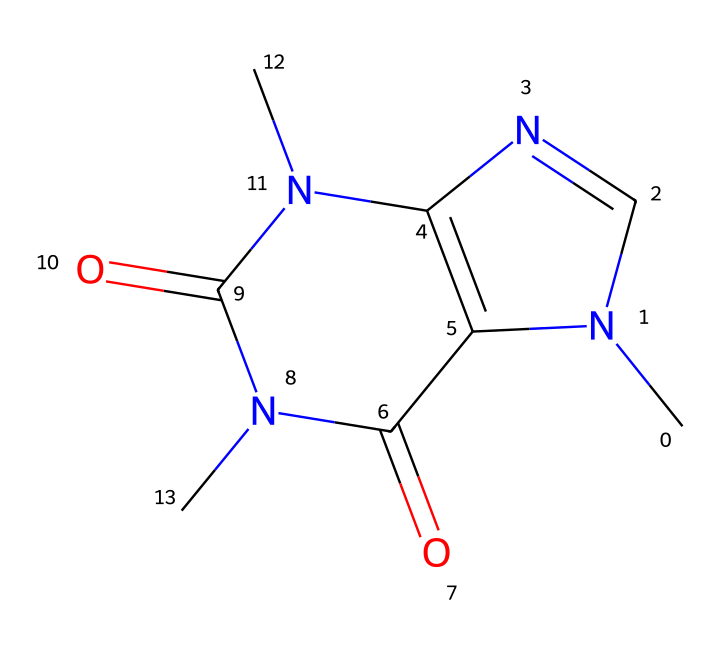What is the molecular formula of this compound? To derive the molecular formula, we identify the individual atoms in the compound using the SMILES notation. The structure reveals the presence of 8 carbon atoms (C), 10 hydrogen atoms (H), 4 nitrogen atoms (N), and 2 oxygen atoms (O). Therefore, the complete molecular formula is C8H10N4O2.
Answer: C8H10N4O2 How many rings are present in the structure? By analyzing the SMILES representation, we can identify the ring closures indicated by the numbers. The structure has two numbered sections, indicating that there are two rings present in the molecular structure.
Answer: 2 What type of chemical functional groups are indicated? The presence of nitrogen atoms in the structure suggests the existence of amine and imine functional groups, whereas the carbonyl groups (indicated by the C=O bonds) indicate the presence of amide or ketone functional groups. Therefore, the functional groups present include amine and amide.
Answer: amine, amide Is this compound considered as an aliphatic or aromatic compound? Although this compound has a complex structure, the presence of certain characteristics such as the lack of continuous cyclic delocalized pi-bonded electrons indicates that the compound is not predominantly aromatic. Instead, its structure aligns more with characteristics of an aliphatic compound with nitrogen substitutions.
Answer: aliphatic What is the total number of nitrogen atoms in the structure? By examining the molecule's structure, we can count the number of nitrogen (N) atoms present. The unique symbols for nitrogen in the SMILES reveal a total of 4 nitrogen atoms in the structure.
Answer: 4 What potential effect does this compound have as a stimulant? The compound's analysis shows the presence of nitrogen atoms, which are common in stimulants like caffeine. The structure suggests that the compound likely acts as a central nervous system stimulant, enhancing alertness and mitigating fatigue.
Answer: stimulant 